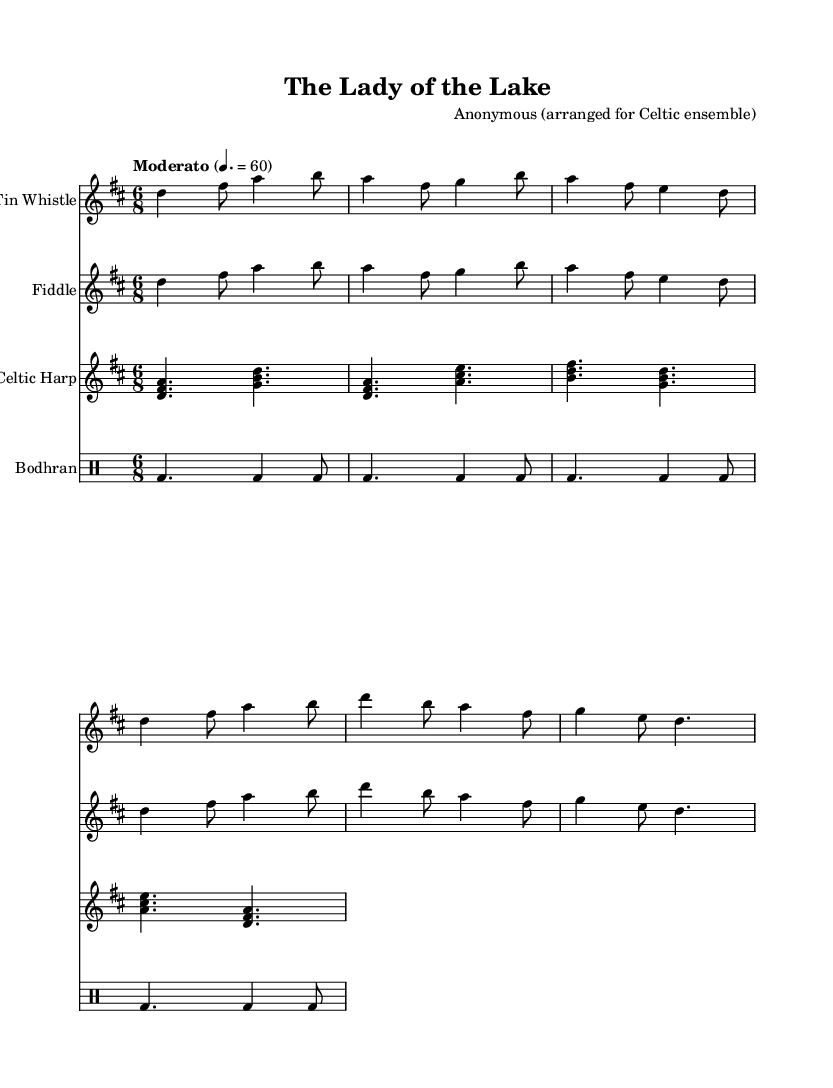What is the key signature of this music? The key signature is D major, which contains two sharps: F# and C#. This is directly indicated in the sheet music at the beginning where the key signature is shown.
Answer: D major What is the time signature of the music? The time signature is 6/8, which is indicated at the beginning of the piece. This informs performers that there are 6 beats in a measure and the eighth note gets the beat.
Answer: 6/8 What is the tempo marking for this piece? The tempo marking is "Moderato," which is placed at the beginning of the music and indicates a moderate speed of the piece. The number "4.= 60" specifies that there are 60 beats per minute.
Answer: Moderato Which instruments are featured in this arrangement? The instruments featured in this arrangement are Tin Whistle, Fiddle, Celtic Harp, and Bodhran. Each instrument is listed as a separate staff at the beginning of the music.
Answer: Tin Whistle, Fiddle, Celtic Harp, Bodhran What is the mood conveyed in the first verse based on the lyrics? The mood conveyed in the first verse is one of mystery and grandeur. The lyrics reference "Avalon's mist" and "a tale unfolds," suggesting a mythical and enchanting atmosphere associated with Arthurian legends.
Answer: Mystery How many measures of music are provided in the Tin Whistle part? The Tin Whistle part contains 6 measures of music, as counted from the notes provided in the staff for this instrument. Each of the phrases is structured to fit neatly within these measures.
Answer: 6 measures 